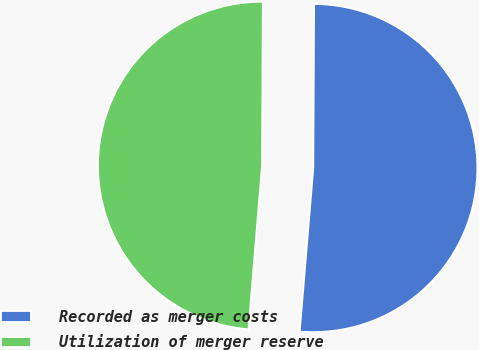<chart> <loc_0><loc_0><loc_500><loc_500><pie_chart><fcel>Recorded as merger costs<fcel>Utilization of merger reserve<nl><fcel>51.24%<fcel>48.76%<nl></chart> 